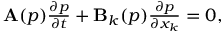Convert formula to latex. <formula><loc_0><loc_0><loc_500><loc_500>\begin{array} { r } { \mathbf A ( p ) \frac { \partial p } { \partial t } + \mathbf B _ { k } ( p ) \frac { \partial p } { \partial x _ { k } } = 0 , } \end{array}</formula> 